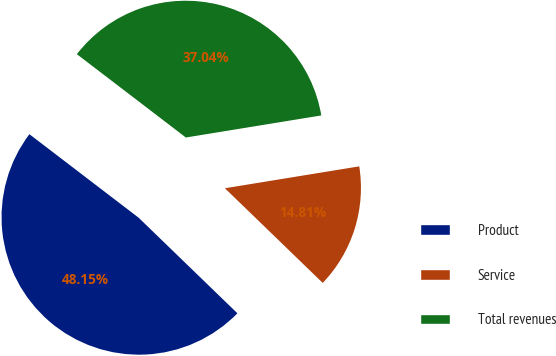<chart> <loc_0><loc_0><loc_500><loc_500><pie_chart><fcel>Product<fcel>Service<fcel>Total revenues<nl><fcel>48.15%<fcel>14.81%<fcel>37.04%<nl></chart> 